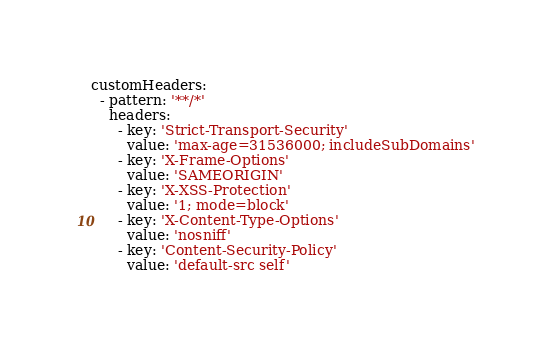<code> <loc_0><loc_0><loc_500><loc_500><_YAML_>customHeaders:
  - pattern: '**/*'
    headers:
      - key: 'Strict-Transport-Security'
        value: 'max-age=31536000; includeSubDomains'
      - key: 'X-Frame-Options'
        value: 'SAMEORIGIN'
      - key: 'X-XSS-Protection'
        value: '1; mode=block'
      - key: 'X-Content-Type-Options'
        value: 'nosniff'
      - key: 'Content-Security-Policy'
        value: 'default-src self'</code> 